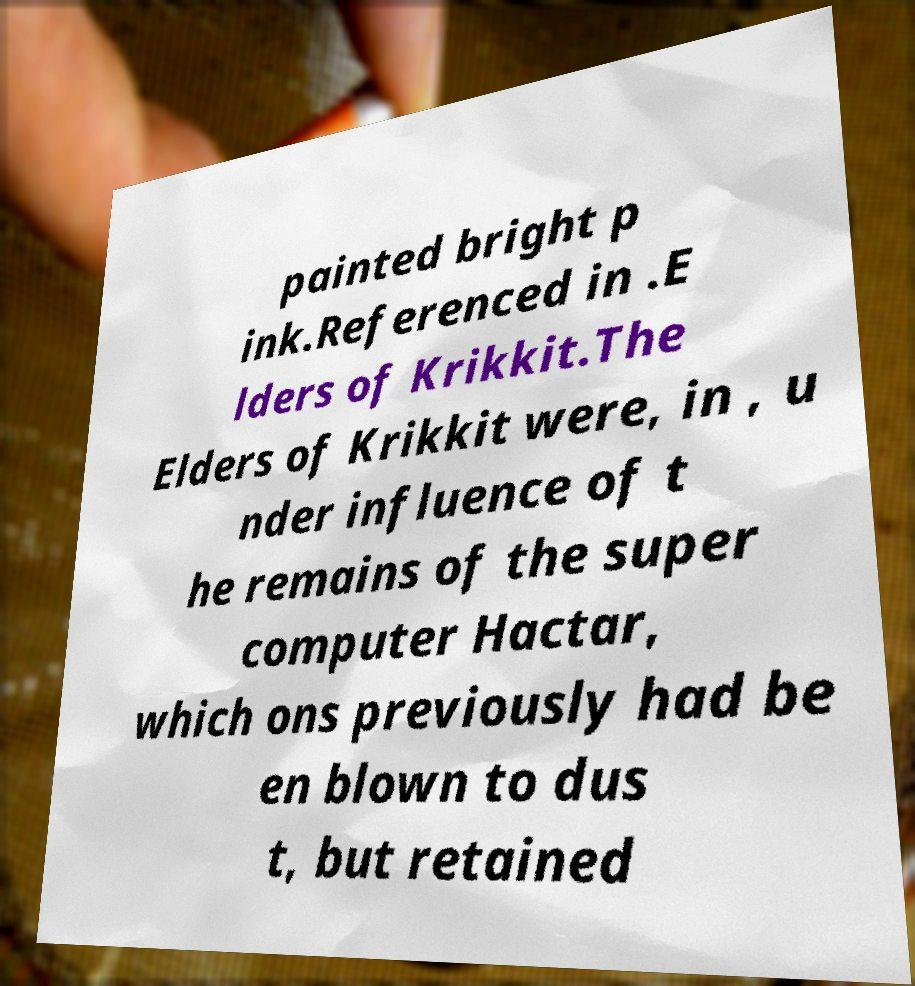Could you assist in decoding the text presented in this image and type it out clearly? painted bright p ink.Referenced in .E lders of Krikkit.The Elders of Krikkit were, in , u nder influence of t he remains of the super computer Hactar, which ons previously had be en blown to dus t, but retained 